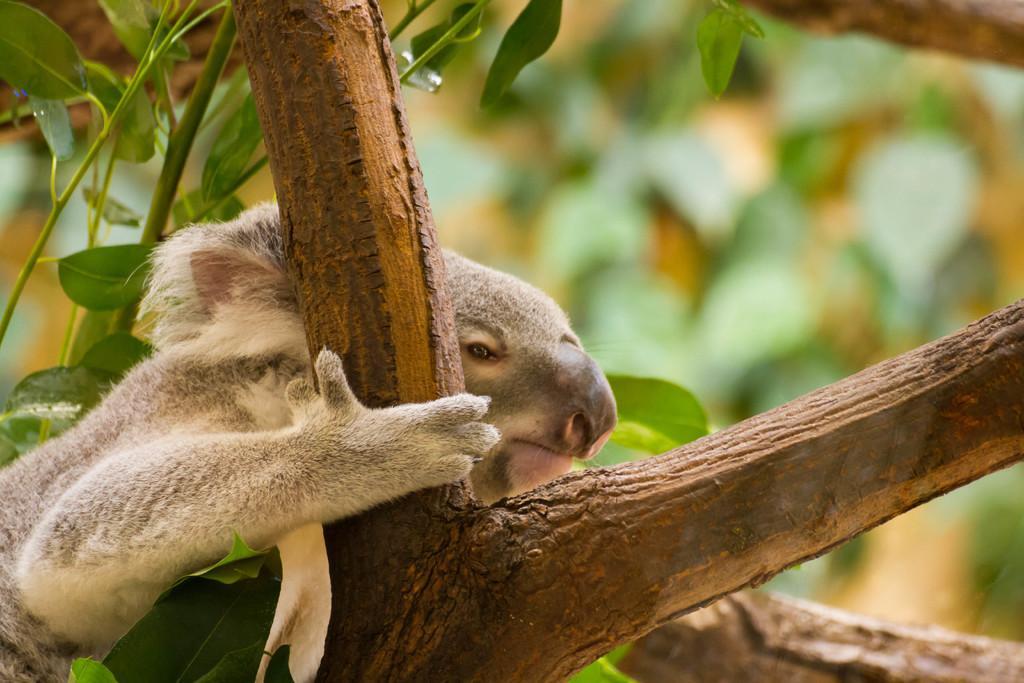Can you describe this image briefly? In this image there is an animal on the branches of a tree, in the background there are leaves. 